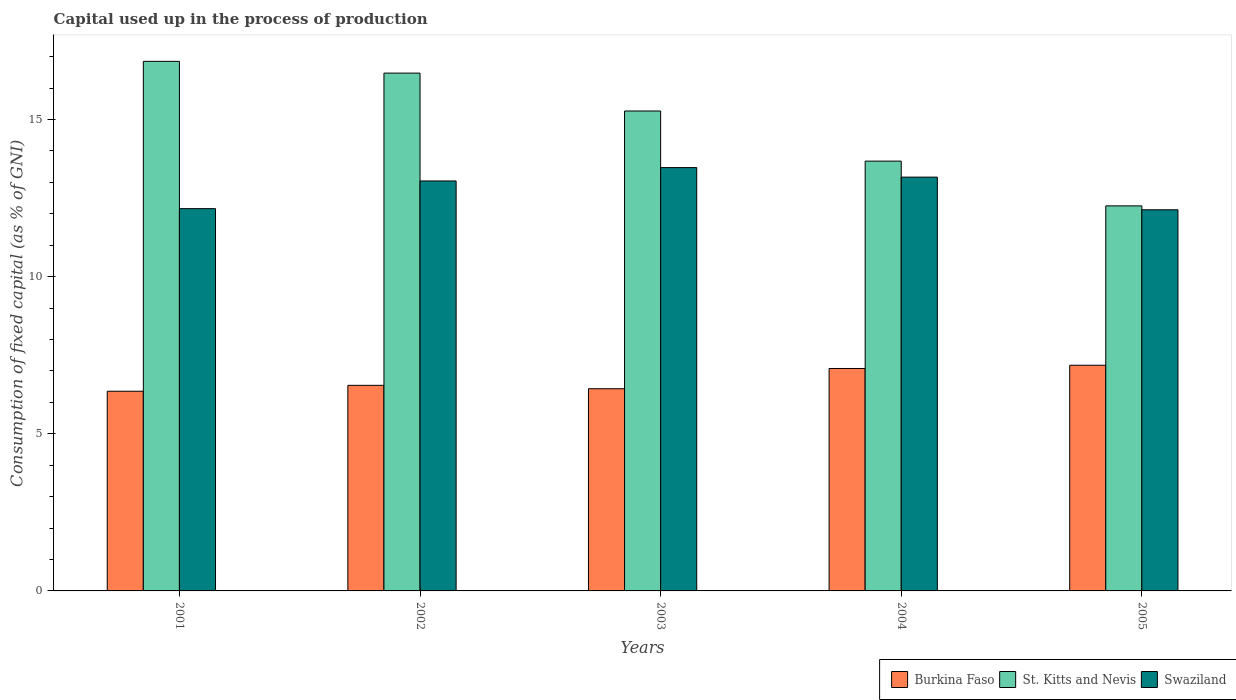How many different coloured bars are there?
Your response must be concise. 3. How many groups of bars are there?
Make the answer very short. 5. How many bars are there on the 2nd tick from the right?
Your answer should be compact. 3. What is the label of the 1st group of bars from the left?
Your response must be concise. 2001. In how many cases, is the number of bars for a given year not equal to the number of legend labels?
Provide a short and direct response. 0. What is the capital used up in the process of production in Swaziland in 2005?
Provide a short and direct response. 12.13. Across all years, what is the maximum capital used up in the process of production in Burkina Faso?
Your answer should be very brief. 7.18. Across all years, what is the minimum capital used up in the process of production in St. Kitts and Nevis?
Offer a very short reply. 12.25. In which year was the capital used up in the process of production in Burkina Faso maximum?
Your answer should be compact. 2005. What is the total capital used up in the process of production in Burkina Faso in the graph?
Your response must be concise. 33.58. What is the difference between the capital used up in the process of production in Swaziland in 2003 and that in 2004?
Provide a short and direct response. 0.3. What is the difference between the capital used up in the process of production in St. Kitts and Nevis in 2002 and the capital used up in the process of production in Swaziland in 2004?
Offer a very short reply. 3.31. What is the average capital used up in the process of production in Burkina Faso per year?
Offer a terse response. 6.72. In the year 2001, what is the difference between the capital used up in the process of production in St. Kitts and Nevis and capital used up in the process of production in Swaziland?
Your answer should be compact. 4.69. In how many years, is the capital used up in the process of production in Swaziland greater than 7 %?
Provide a short and direct response. 5. What is the ratio of the capital used up in the process of production in Swaziland in 2003 to that in 2005?
Your response must be concise. 1.11. Is the capital used up in the process of production in Swaziland in 2001 less than that in 2004?
Ensure brevity in your answer.  Yes. Is the difference between the capital used up in the process of production in St. Kitts and Nevis in 2001 and 2005 greater than the difference between the capital used up in the process of production in Swaziland in 2001 and 2005?
Offer a very short reply. Yes. What is the difference between the highest and the second highest capital used up in the process of production in Burkina Faso?
Your answer should be compact. 0.1. What is the difference between the highest and the lowest capital used up in the process of production in St. Kitts and Nevis?
Give a very brief answer. 4.6. Is the sum of the capital used up in the process of production in Burkina Faso in 2003 and 2005 greater than the maximum capital used up in the process of production in St. Kitts and Nevis across all years?
Your response must be concise. No. What does the 1st bar from the left in 2003 represents?
Make the answer very short. Burkina Faso. What does the 1st bar from the right in 2004 represents?
Provide a short and direct response. Swaziland. Are the values on the major ticks of Y-axis written in scientific E-notation?
Make the answer very short. No. Does the graph contain any zero values?
Your answer should be compact. No. How many legend labels are there?
Keep it short and to the point. 3. What is the title of the graph?
Give a very brief answer. Capital used up in the process of production. Does "Euro area" appear as one of the legend labels in the graph?
Your answer should be very brief. No. What is the label or title of the Y-axis?
Make the answer very short. Consumption of fixed capital (as % of GNI). What is the Consumption of fixed capital (as % of GNI) in Burkina Faso in 2001?
Give a very brief answer. 6.35. What is the Consumption of fixed capital (as % of GNI) of St. Kitts and Nevis in 2001?
Your answer should be compact. 16.85. What is the Consumption of fixed capital (as % of GNI) of Swaziland in 2001?
Ensure brevity in your answer.  12.16. What is the Consumption of fixed capital (as % of GNI) in Burkina Faso in 2002?
Ensure brevity in your answer.  6.54. What is the Consumption of fixed capital (as % of GNI) of St. Kitts and Nevis in 2002?
Keep it short and to the point. 16.47. What is the Consumption of fixed capital (as % of GNI) in Swaziland in 2002?
Offer a very short reply. 13.04. What is the Consumption of fixed capital (as % of GNI) in Burkina Faso in 2003?
Your response must be concise. 6.43. What is the Consumption of fixed capital (as % of GNI) of St. Kitts and Nevis in 2003?
Your answer should be compact. 15.27. What is the Consumption of fixed capital (as % of GNI) of Swaziland in 2003?
Give a very brief answer. 13.47. What is the Consumption of fixed capital (as % of GNI) of Burkina Faso in 2004?
Provide a succinct answer. 7.08. What is the Consumption of fixed capital (as % of GNI) in St. Kitts and Nevis in 2004?
Make the answer very short. 13.67. What is the Consumption of fixed capital (as % of GNI) in Swaziland in 2004?
Offer a terse response. 13.16. What is the Consumption of fixed capital (as % of GNI) of Burkina Faso in 2005?
Ensure brevity in your answer.  7.18. What is the Consumption of fixed capital (as % of GNI) in St. Kitts and Nevis in 2005?
Your answer should be compact. 12.25. What is the Consumption of fixed capital (as % of GNI) of Swaziland in 2005?
Your response must be concise. 12.13. Across all years, what is the maximum Consumption of fixed capital (as % of GNI) of Burkina Faso?
Give a very brief answer. 7.18. Across all years, what is the maximum Consumption of fixed capital (as % of GNI) in St. Kitts and Nevis?
Offer a terse response. 16.85. Across all years, what is the maximum Consumption of fixed capital (as % of GNI) in Swaziland?
Make the answer very short. 13.47. Across all years, what is the minimum Consumption of fixed capital (as % of GNI) in Burkina Faso?
Your answer should be very brief. 6.35. Across all years, what is the minimum Consumption of fixed capital (as % of GNI) in St. Kitts and Nevis?
Provide a short and direct response. 12.25. Across all years, what is the minimum Consumption of fixed capital (as % of GNI) in Swaziland?
Keep it short and to the point. 12.13. What is the total Consumption of fixed capital (as % of GNI) of Burkina Faso in the graph?
Provide a succinct answer. 33.58. What is the total Consumption of fixed capital (as % of GNI) of St. Kitts and Nevis in the graph?
Your answer should be compact. 74.51. What is the total Consumption of fixed capital (as % of GNI) in Swaziland in the graph?
Provide a short and direct response. 63.96. What is the difference between the Consumption of fixed capital (as % of GNI) of Burkina Faso in 2001 and that in 2002?
Give a very brief answer. -0.19. What is the difference between the Consumption of fixed capital (as % of GNI) of St. Kitts and Nevis in 2001 and that in 2002?
Provide a succinct answer. 0.37. What is the difference between the Consumption of fixed capital (as % of GNI) of Swaziland in 2001 and that in 2002?
Make the answer very short. -0.88. What is the difference between the Consumption of fixed capital (as % of GNI) of Burkina Faso in 2001 and that in 2003?
Keep it short and to the point. -0.08. What is the difference between the Consumption of fixed capital (as % of GNI) in St. Kitts and Nevis in 2001 and that in 2003?
Provide a short and direct response. 1.58. What is the difference between the Consumption of fixed capital (as % of GNI) of Swaziland in 2001 and that in 2003?
Keep it short and to the point. -1.31. What is the difference between the Consumption of fixed capital (as % of GNI) in Burkina Faso in 2001 and that in 2004?
Your response must be concise. -0.72. What is the difference between the Consumption of fixed capital (as % of GNI) of St. Kitts and Nevis in 2001 and that in 2004?
Provide a short and direct response. 3.17. What is the difference between the Consumption of fixed capital (as % of GNI) in Swaziland in 2001 and that in 2004?
Your answer should be compact. -1. What is the difference between the Consumption of fixed capital (as % of GNI) in Burkina Faso in 2001 and that in 2005?
Offer a very short reply. -0.83. What is the difference between the Consumption of fixed capital (as % of GNI) in St. Kitts and Nevis in 2001 and that in 2005?
Give a very brief answer. 4.6. What is the difference between the Consumption of fixed capital (as % of GNI) in Swaziland in 2001 and that in 2005?
Offer a very short reply. 0.04. What is the difference between the Consumption of fixed capital (as % of GNI) of Burkina Faso in 2002 and that in 2003?
Ensure brevity in your answer.  0.11. What is the difference between the Consumption of fixed capital (as % of GNI) in St. Kitts and Nevis in 2002 and that in 2003?
Your response must be concise. 1.21. What is the difference between the Consumption of fixed capital (as % of GNI) in Swaziland in 2002 and that in 2003?
Ensure brevity in your answer.  -0.42. What is the difference between the Consumption of fixed capital (as % of GNI) in Burkina Faso in 2002 and that in 2004?
Provide a succinct answer. -0.54. What is the difference between the Consumption of fixed capital (as % of GNI) of St. Kitts and Nevis in 2002 and that in 2004?
Make the answer very short. 2.8. What is the difference between the Consumption of fixed capital (as % of GNI) of Swaziland in 2002 and that in 2004?
Keep it short and to the point. -0.12. What is the difference between the Consumption of fixed capital (as % of GNI) of Burkina Faso in 2002 and that in 2005?
Your answer should be very brief. -0.64. What is the difference between the Consumption of fixed capital (as % of GNI) of St. Kitts and Nevis in 2002 and that in 2005?
Your response must be concise. 4.22. What is the difference between the Consumption of fixed capital (as % of GNI) of Swaziland in 2002 and that in 2005?
Offer a terse response. 0.92. What is the difference between the Consumption of fixed capital (as % of GNI) of Burkina Faso in 2003 and that in 2004?
Your answer should be compact. -0.64. What is the difference between the Consumption of fixed capital (as % of GNI) of St. Kitts and Nevis in 2003 and that in 2004?
Provide a succinct answer. 1.59. What is the difference between the Consumption of fixed capital (as % of GNI) of Swaziland in 2003 and that in 2004?
Keep it short and to the point. 0.3. What is the difference between the Consumption of fixed capital (as % of GNI) in Burkina Faso in 2003 and that in 2005?
Offer a terse response. -0.75. What is the difference between the Consumption of fixed capital (as % of GNI) in St. Kitts and Nevis in 2003 and that in 2005?
Offer a terse response. 3.02. What is the difference between the Consumption of fixed capital (as % of GNI) in Swaziland in 2003 and that in 2005?
Offer a very short reply. 1.34. What is the difference between the Consumption of fixed capital (as % of GNI) of Burkina Faso in 2004 and that in 2005?
Keep it short and to the point. -0.1. What is the difference between the Consumption of fixed capital (as % of GNI) in St. Kitts and Nevis in 2004 and that in 2005?
Give a very brief answer. 1.42. What is the difference between the Consumption of fixed capital (as % of GNI) in Swaziland in 2004 and that in 2005?
Provide a short and direct response. 1.04. What is the difference between the Consumption of fixed capital (as % of GNI) in Burkina Faso in 2001 and the Consumption of fixed capital (as % of GNI) in St. Kitts and Nevis in 2002?
Provide a short and direct response. -10.12. What is the difference between the Consumption of fixed capital (as % of GNI) of Burkina Faso in 2001 and the Consumption of fixed capital (as % of GNI) of Swaziland in 2002?
Offer a very short reply. -6.69. What is the difference between the Consumption of fixed capital (as % of GNI) in St. Kitts and Nevis in 2001 and the Consumption of fixed capital (as % of GNI) in Swaziland in 2002?
Provide a succinct answer. 3.81. What is the difference between the Consumption of fixed capital (as % of GNI) of Burkina Faso in 2001 and the Consumption of fixed capital (as % of GNI) of St. Kitts and Nevis in 2003?
Your response must be concise. -8.92. What is the difference between the Consumption of fixed capital (as % of GNI) of Burkina Faso in 2001 and the Consumption of fixed capital (as % of GNI) of Swaziland in 2003?
Offer a very short reply. -7.11. What is the difference between the Consumption of fixed capital (as % of GNI) in St. Kitts and Nevis in 2001 and the Consumption of fixed capital (as % of GNI) in Swaziland in 2003?
Offer a very short reply. 3.38. What is the difference between the Consumption of fixed capital (as % of GNI) in Burkina Faso in 2001 and the Consumption of fixed capital (as % of GNI) in St. Kitts and Nevis in 2004?
Provide a short and direct response. -7.32. What is the difference between the Consumption of fixed capital (as % of GNI) of Burkina Faso in 2001 and the Consumption of fixed capital (as % of GNI) of Swaziland in 2004?
Provide a short and direct response. -6.81. What is the difference between the Consumption of fixed capital (as % of GNI) of St. Kitts and Nevis in 2001 and the Consumption of fixed capital (as % of GNI) of Swaziland in 2004?
Offer a very short reply. 3.68. What is the difference between the Consumption of fixed capital (as % of GNI) of Burkina Faso in 2001 and the Consumption of fixed capital (as % of GNI) of St. Kitts and Nevis in 2005?
Provide a succinct answer. -5.9. What is the difference between the Consumption of fixed capital (as % of GNI) of Burkina Faso in 2001 and the Consumption of fixed capital (as % of GNI) of Swaziland in 2005?
Make the answer very short. -5.77. What is the difference between the Consumption of fixed capital (as % of GNI) of St. Kitts and Nevis in 2001 and the Consumption of fixed capital (as % of GNI) of Swaziland in 2005?
Keep it short and to the point. 4.72. What is the difference between the Consumption of fixed capital (as % of GNI) of Burkina Faso in 2002 and the Consumption of fixed capital (as % of GNI) of St. Kitts and Nevis in 2003?
Your response must be concise. -8.73. What is the difference between the Consumption of fixed capital (as % of GNI) of Burkina Faso in 2002 and the Consumption of fixed capital (as % of GNI) of Swaziland in 2003?
Give a very brief answer. -6.93. What is the difference between the Consumption of fixed capital (as % of GNI) in St. Kitts and Nevis in 2002 and the Consumption of fixed capital (as % of GNI) in Swaziland in 2003?
Keep it short and to the point. 3.01. What is the difference between the Consumption of fixed capital (as % of GNI) in Burkina Faso in 2002 and the Consumption of fixed capital (as % of GNI) in St. Kitts and Nevis in 2004?
Your response must be concise. -7.13. What is the difference between the Consumption of fixed capital (as % of GNI) of Burkina Faso in 2002 and the Consumption of fixed capital (as % of GNI) of Swaziland in 2004?
Offer a very short reply. -6.62. What is the difference between the Consumption of fixed capital (as % of GNI) in St. Kitts and Nevis in 2002 and the Consumption of fixed capital (as % of GNI) in Swaziland in 2004?
Your answer should be very brief. 3.31. What is the difference between the Consumption of fixed capital (as % of GNI) in Burkina Faso in 2002 and the Consumption of fixed capital (as % of GNI) in St. Kitts and Nevis in 2005?
Keep it short and to the point. -5.71. What is the difference between the Consumption of fixed capital (as % of GNI) in Burkina Faso in 2002 and the Consumption of fixed capital (as % of GNI) in Swaziland in 2005?
Make the answer very short. -5.58. What is the difference between the Consumption of fixed capital (as % of GNI) of St. Kitts and Nevis in 2002 and the Consumption of fixed capital (as % of GNI) of Swaziland in 2005?
Keep it short and to the point. 4.35. What is the difference between the Consumption of fixed capital (as % of GNI) of Burkina Faso in 2003 and the Consumption of fixed capital (as % of GNI) of St. Kitts and Nevis in 2004?
Your answer should be compact. -7.24. What is the difference between the Consumption of fixed capital (as % of GNI) in Burkina Faso in 2003 and the Consumption of fixed capital (as % of GNI) in Swaziland in 2004?
Provide a short and direct response. -6.73. What is the difference between the Consumption of fixed capital (as % of GNI) of St. Kitts and Nevis in 2003 and the Consumption of fixed capital (as % of GNI) of Swaziland in 2004?
Keep it short and to the point. 2.1. What is the difference between the Consumption of fixed capital (as % of GNI) in Burkina Faso in 2003 and the Consumption of fixed capital (as % of GNI) in St. Kitts and Nevis in 2005?
Your answer should be compact. -5.82. What is the difference between the Consumption of fixed capital (as % of GNI) in Burkina Faso in 2003 and the Consumption of fixed capital (as % of GNI) in Swaziland in 2005?
Your response must be concise. -5.69. What is the difference between the Consumption of fixed capital (as % of GNI) of St. Kitts and Nevis in 2003 and the Consumption of fixed capital (as % of GNI) of Swaziland in 2005?
Your answer should be compact. 3.14. What is the difference between the Consumption of fixed capital (as % of GNI) in Burkina Faso in 2004 and the Consumption of fixed capital (as % of GNI) in St. Kitts and Nevis in 2005?
Provide a short and direct response. -5.17. What is the difference between the Consumption of fixed capital (as % of GNI) in Burkina Faso in 2004 and the Consumption of fixed capital (as % of GNI) in Swaziland in 2005?
Give a very brief answer. -5.05. What is the difference between the Consumption of fixed capital (as % of GNI) in St. Kitts and Nevis in 2004 and the Consumption of fixed capital (as % of GNI) in Swaziland in 2005?
Your answer should be very brief. 1.55. What is the average Consumption of fixed capital (as % of GNI) of Burkina Faso per year?
Your answer should be compact. 6.72. What is the average Consumption of fixed capital (as % of GNI) in St. Kitts and Nevis per year?
Offer a terse response. 14.9. What is the average Consumption of fixed capital (as % of GNI) of Swaziland per year?
Offer a very short reply. 12.79. In the year 2001, what is the difference between the Consumption of fixed capital (as % of GNI) of Burkina Faso and Consumption of fixed capital (as % of GNI) of St. Kitts and Nevis?
Give a very brief answer. -10.49. In the year 2001, what is the difference between the Consumption of fixed capital (as % of GNI) in Burkina Faso and Consumption of fixed capital (as % of GNI) in Swaziland?
Your answer should be compact. -5.81. In the year 2001, what is the difference between the Consumption of fixed capital (as % of GNI) in St. Kitts and Nevis and Consumption of fixed capital (as % of GNI) in Swaziland?
Provide a short and direct response. 4.69. In the year 2002, what is the difference between the Consumption of fixed capital (as % of GNI) in Burkina Faso and Consumption of fixed capital (as % of GNI) in St. Kitts and Nevis?
Provide a succinct answer. -9.93. In the year 2002, what is the difference between the Consumption of fixed capital (as % of GNI) of Burkina Faso and Consumption of fixed capital (as % of GNI) of Swaziland?
Your response must be concise. -6.5. In the year 2002, what is the difference between the Consumption of fixed capital (as % of GNI) in St. Kitts and Nevis and Consumption of fixed capital (as % of GNI) in Swaziland?
Provide a succinct answer. 3.43. In the year 2003, what is the difference between the Consumption of fixed capital (as % of GNI) in Burkina Faso and Consumption of fixed capital (as % of GNI) in St. Kitts and Nevis?
Make the answer very short. -8.84. In the year 2003, what is the difference between the Consumption of fixed capital (as % of GNI) of Burkina Faso and Consumption of fixed capital (as % of GNI) of Swaziland?
Give a very brief answer. -7.03. In the year 2003, what is the difference between the Consumption of fixed capital (as % of GNI) of St. Kitts and Nevis and Consumption of fixed capital (as % of GNI) of Swaziland?
Your answer should be very brief. 1.8. In the year 2004, what is the difference between the Consumption of fixed capital (as % of GNI) in Burkina Faso and Consumption of fixed capital (as % of GNI) in St. Kitts and Nevis?
Keep it short and to the point. -6.6. In the year 2004, what is the difference between the Consumption of fixed capital (as % of GNI) in Burkina Faso and Consumption of fixed capital (as % of GNI) in Swaziland?
Your answer should be compact. -6.09. In the year 2004, what is the difference between the Consumption of fixed capital (as % of GNI) in St. Kitts and Nevis and Consumption of fixed capital (as % of GNI) in Swaziland?
Give a very brief answer. 0.51. In the year 2005, what is the difference between the Consumption of fixed capital (as % of GNI) of Burkina Faso and Consumption of fixed capital (as % of GNI) of St. Kitts and Nevis?
Offer a very short reply. -5.07. In the year 2005, what is the difference between the Consumption of fixed capital (as % of GNI) of Burkina Faso and Consumption of fixed capital (as % of GNI) of Swaziland?
Offer a terse response. -4.95. In the year 2005, what is the difference between the Consumption of fixed capital (as % of GNI) in St. Kitts and Nevis and Consumption of fixed capital (as % of GNI) in Swaziland?
Ensure brevity in your answer.  0.12. What is the ratio of the Consumption of fixed capital (as % of GNI) of Burkina Faso in 2001 to that in 2002?
Your response must be concise. 0.97. What is the ratio of the Consumption of fixed capital (as % of GNI) of St. Kitts and Nevis in 2001 to that in 2002?
Make the answer very short. 1.02. What is the ratio of the Consumption of fixed capital (as % of GNI) of Swaziland in 2001 to that in 2002?
Make the answer very short. 0.93. What is the ratio of the Consumption of fixed capital (as % of GNI) in St. Kitts and Nevis in 2001 to that in 2003?
Your answer should be compact. 1.1. What is the ratio of the Consumption of fixed capital (as % of GNI) of Swaziland in 2001 to that in 2003?
Make the answer very short. 0.9. What is the ratio of the Consumption of fixed capital (as % of GNI) in Burkina Faso in 2001 to that in 2004?
Offer a very short reply. 0.9. What is the ratio of the Consumption of fixed capital (as % of GNI) in St. Kitts and Nevis in 2001 to that in 2004?
Offer a very short reply. 1.23. What is the ratio of the Consumption of fixed capital (as % of GNI) of Swaziland in 2001 to that in 2004?
Keep it short and to the point. 0.92. What is the ratio of the Consumption of fixed capital (as % of GNI) in Burkina Faso in 2001 to that in 2005?
Offer a terse response. 0.88. What is the ratio of the Consumption of fixed capital (as % of GNI) in St. Kitts and Nevis in 2001 to that in 2005?
Provide a short and direct response. 1.38. What is the ratio of the Consumption of fixed capital (as % of GNI) of Swaziland in 2001 to that in 2005?
Your answer should be very brief. 1. What is the ratio of the Consumption of fixed capital (as % of GNI) in Burkina Faso in 2002 to that in 2003?
Your answer should be very brief. 1.02. What is the ratio of the Consumption of fixed capital (as % of GNI) of St. Kitts and Nevis in 2002 to that in 2003?
Your response must be concise. 1.08. What is the ratio of the Consumption of fixed capital (as % of GNI) in Swaziland in 2002 to that in 2003?
Provide a succinct answer. 0.97. What is the ratio of the Consumption of fixed capital (as % of GNI) of Burkina Faso in 2002 to that in 2004?
Give a very brief answer. 0.92. What is the ratio of the Consumption of fixed capital (as % of GNI) of St. Kitts and Nevis in 2002 to that in 2004?
Make the answer very short. 1.2. What is the ratio of the Consumption of fixed capital (as % of GNI) in Swaziland in 2002 to that in 2004?
Offer a terse response. 0.99. What is the ratio of the Consumption of fixed capital (as % of GNI) of Burkina Faso in 2002 to that in 2005?
Offer a terse response. 0.91. What is the ratio of the Consumption of fixed capital (as % of GNI) of St. Kitts and Nevis in 2002 to that in 2005?
Make the answer very short. 1.34. What is the ratio of the Consumption of fixed capital (as % of GNI) of Swaziland in 2002 to that in 2005?
Give a very brief answer. 1.08. What is the ratio of the Consumption of fixed capital (as % of GNI) of St. Kitts and Nevis in 2003 to that in 2004?
Offer a very short reply. 1.12. What is the ratio of the Consumption of fixed capital (as % of GNI) of Swaziland in 2003 to that in 2004?
Give a very brief answer. 1.02. What is the ratio of the Consumption of fixed capital (as % of GNI) in Burkina Faso in 2003 to that in 2005?
Provide a short and direct response. 0.9. What is the ratio of the Consumption of fixed capital (as % of GNI) of St. Kitts and Nevis in 2003 to that in 2005?
Make the answer very short. 1.25. What is the ratio of the Consumption of fixed capital (as % of GNI) of Swaziland in 2003 to that in 2005?
Offer a very short reply. 1.11. What is the ratio of the Consumption of fixed capital (as % of GNI) in Burkina Faso in 2004 to that in 2005?
Provide a succinct answer. 0.99. What is the ratio of the Consumption of fixed capital (as % of GNI) in St. Kitts and Nevis in 2004 to that in 2005?
Provide a short and direct response. 1.12. What is the ratio of the Consumption of fixed capital (as % of GNI) in Swaziland in 2004 to that in 2005?
Provide a short and direct response. 1.09. What is the difference between the highest and the second highest Consumption of fixed capital (as % of GNI) of Burkina Faso?
Your answer should be compact. 0.1. What is the difference between the highest and the second highest Consumption of fixed capital (as % of GNI) in St. Kitts and Nevis?
Keep it short and to the point. 0.37. What is the difference between the highest and the second highest Consumption of fixed capital (as % of GNI) in Swaziland?
Keep it short and to the point. 0.3. What is the difference between the highest and the lowest Consumption of fixed capital (as % of GNI) of Burkina Faso?
Keep it short and to the point. 0.83. What is the difference between the highest and the lowest Consumption of fixed capital (as % of GNI) in St. Kitts and Nevis?
Provide a short and direct response. 4.6. What is the difference between the highest and the lowest Consumption of fixed capital (as % of GNI) of Swaziland?
Ensure brevity in your answer.  1.34. 